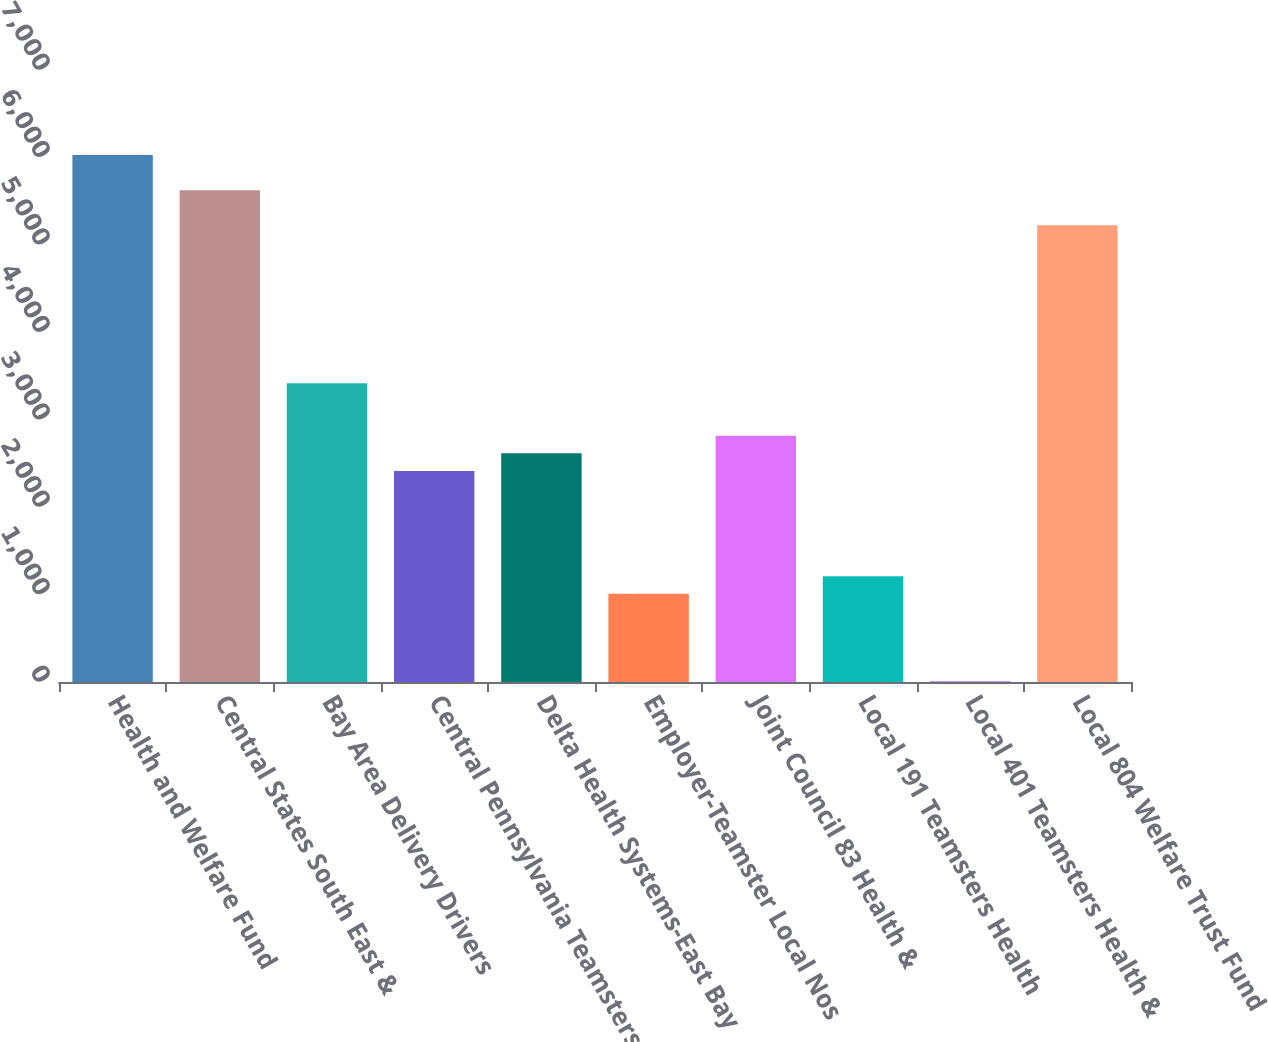Convert chart. <chart><loc_0><loc_0><loc_500><loc_500><bar_chart><fcel>Health and Welfare Fund<fcel>Central States South East &<fcel>Bay Area Delivery Drivers<fcel>Central Pennsylvania Teamsters<fcel>Delta Health Systems-East Bay<fcel>Employer-Teamster Local Nos<fcel>Joint Council 83 Health &<fcel>Local 191 Teamsters Health<fcel>Local 401 Teamsters Health &<fcel>Local 804 Welfare Trust Fund<nl><fcel>6027<fcel>5625.6<fcel>3417.9<fcel>2414.4<fcel>2615.1<fcel>1009.5<fcel>2815.8<fcel>1210.2<fcel>6<fcel>5224.2<nl></chart> 